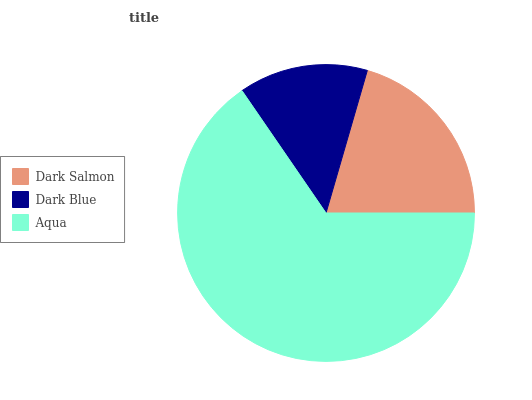Is Dark Blue the minimum?
Answer yes or no. Yes. Is Aqua the maximum?
Answer yes or no. Yes. Is Aqua the minimum?
Answer yes or no. No. Is Dark Blue the maximum?
Answer yes or no. No. Is Aqua greater than Dark Blue?
Answer yes or no. Yes. Is Dark Blue less than Aqua?
Answer yes or no. Yes. Is Dark Blue greater than Aqua?
Answer yes or no. No. Is Aqua less than Dark Blue?
Answer yes or no. No. Is Dark Salmon the high median?
Answer yes or no. Yes. Is Dark Salmon the low median?
Answer yes or no. Yes. Is Dark Blue the high median?
Answer yes or no. No. Is Dark Blue the low median?
Answer yes or no. No. 